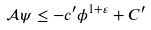<formula> <loc_0><loc_0><loc_500><loc_500>\mathcal { A } \psi \leq - c ^ { \prime } \phi ^ { 1 + \varepsilon } + C ^ { \prime }</formula> 